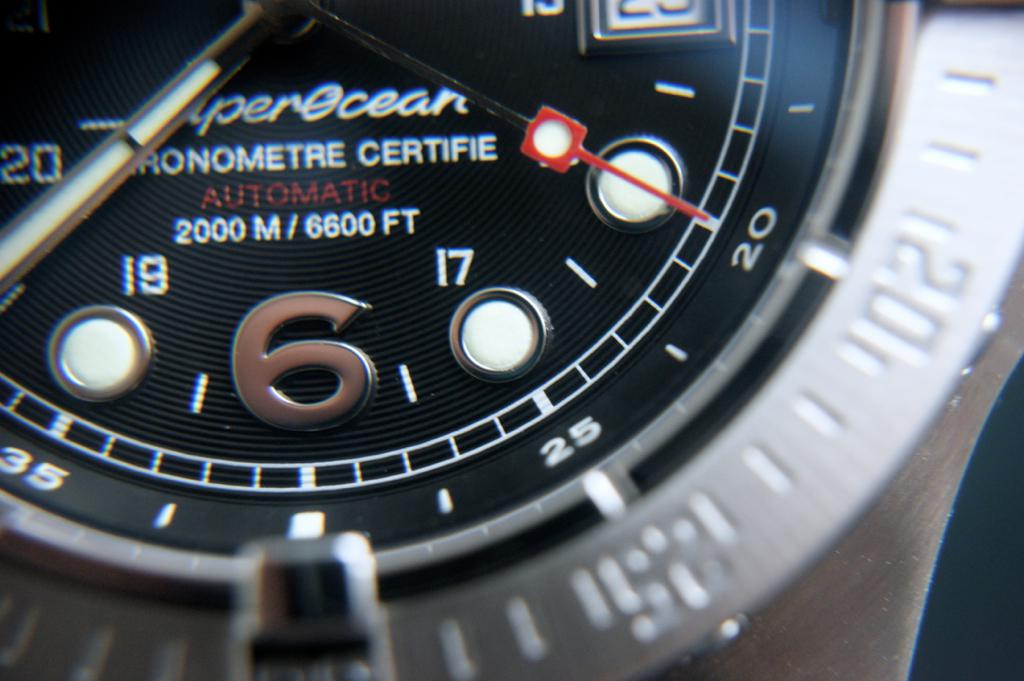Why would someone prefer a watch with a 2000 meter water resistance? A watch with 2000 meter water resistance is ideal for professional divers who need reliable equipment for deep-sea exploration. It also appeals to watch enthusiasts and collectors who appreciate advanced mechanical engineering and high performance in extreme conditions. 